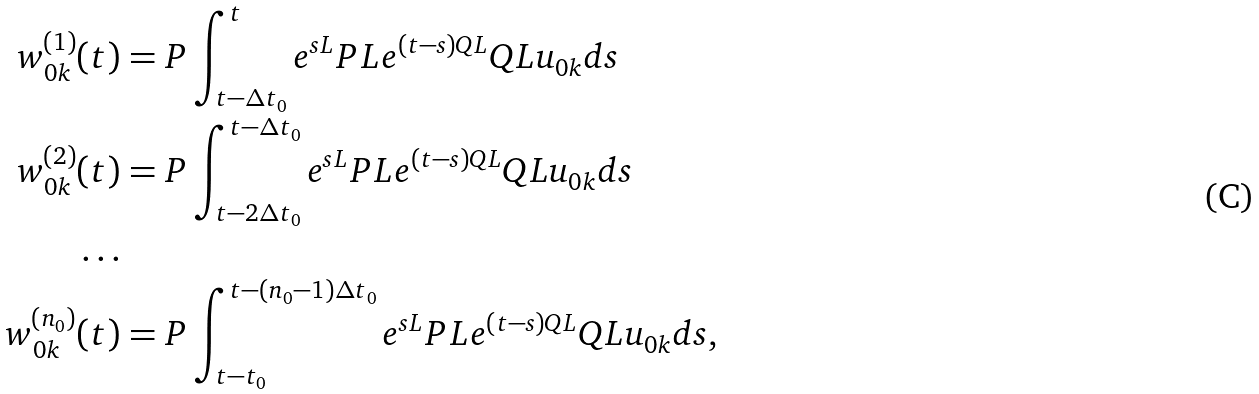<formula> <loc_0><loc_0><loc_500><loc_500>w _ { 0 k } ^ { ( 1 ) } ( t ) & = P \int _ { t - \Delta t _ { 0 } } ^ { t } e ^ { s L } P L e ^ { ( t - s ) Q L } Q L u _ { 0 k } d s \\ w _ { 0 k } ^ { ( 2 ) } ( t ) & = P \int _ { t - 2 \Delta t _ { 0 } } ^ { t - \Delta t _ { 0 } } e ^ { s L } P L e ^ { ( t - s ) Q L } Q L u _ { 0 k } d s \\ \dots & \\ w _ { 0 k } ^ { ( n _ { 0 } ) } ( t ) & = P \int _ { t - t _ { 0 } } ^ { t - ( n _ { 0 } - 1 ) \Delta t _ { 0 } } e ^ { s L } P L e ^ { ( t - s ) Q L } Q L u _ { 0 k } d s ,</formula> 